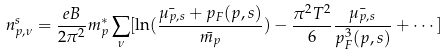Convert formula to latex. <formula><loc_0><loc_0><loc_500><loc_500>n _ { p , \nu } ^ { s } = \frac { e B } { 2 \pi ^ { 2 } } m _ { p } ^ { * } \sum _ { \nu } [ \ln ( \frac { \bar { \mu _ { p , s } } + p _ { F } ( p , s ) } { \bar { m _ { p } } } ) - \frac { \pi ^ { 2 } T ^ { 2 } } { 6 } \frac { \bar { \mu _ { p , s } } } { p _ { F } ^ { 3 } ( p , s ) } + \cdots ]</formula> 